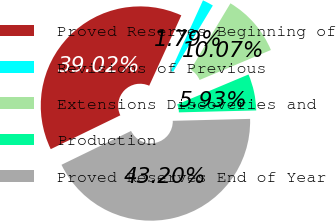Convert chart. <chart><loc_0><loc_0><loc_500><loc_500><pie_chart><fcel>Proved Reserves Beginning of<fcel>Revisions of Previous<fcel>Extensions Discoveries and<fcel>Production<fcel>Proved Reserves End of Year<nl><fcel>39.02%<fcel>1.79%<fcel>10.07%<fcel>5.93%<fcel>43.2%<nl></chart> 